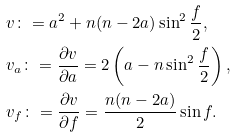Convert formula to latex. <formula><loc_0><loc_0><loc_500><loc_500>& v \colon = a ^ { 2 } + n ( n - 2 a ) \sin ^ { 2 } \frac { f } { 2 } , \\ & v _ { a } \colon = \frac { \partial { v } } { \partial { a } } = 2 \left ( a - n \sin ^ { 2 } { \frac { f } { 2 } } \right ) , \\ & v _ { f } \colon = \frac { \partial { v } } { \partial { f } } = \frac { n ( n - 2 a ) } { 2 } \sin { f } .</formula> 